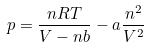Convert formula to latex. <formula><loc_0><loc_0><loc_500><loc_500>p = \frac { n R T } { V - n b } - a \frac { n ^ { 2 } } { V ^ { 2 } }</formula> 